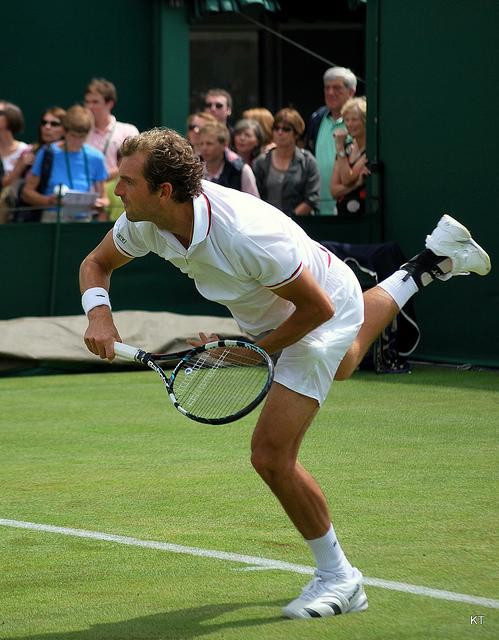What sport is the man playing?
Short answer required. Tennis. What color are the man's shoes?
Quick response, please. White. Which foot is not completely on the ground?
Give a very brief answer. Right. Are all the spectators following the ball?
Write a very short answer. No. Is the warming up for the match?
Answer briefly. No. 